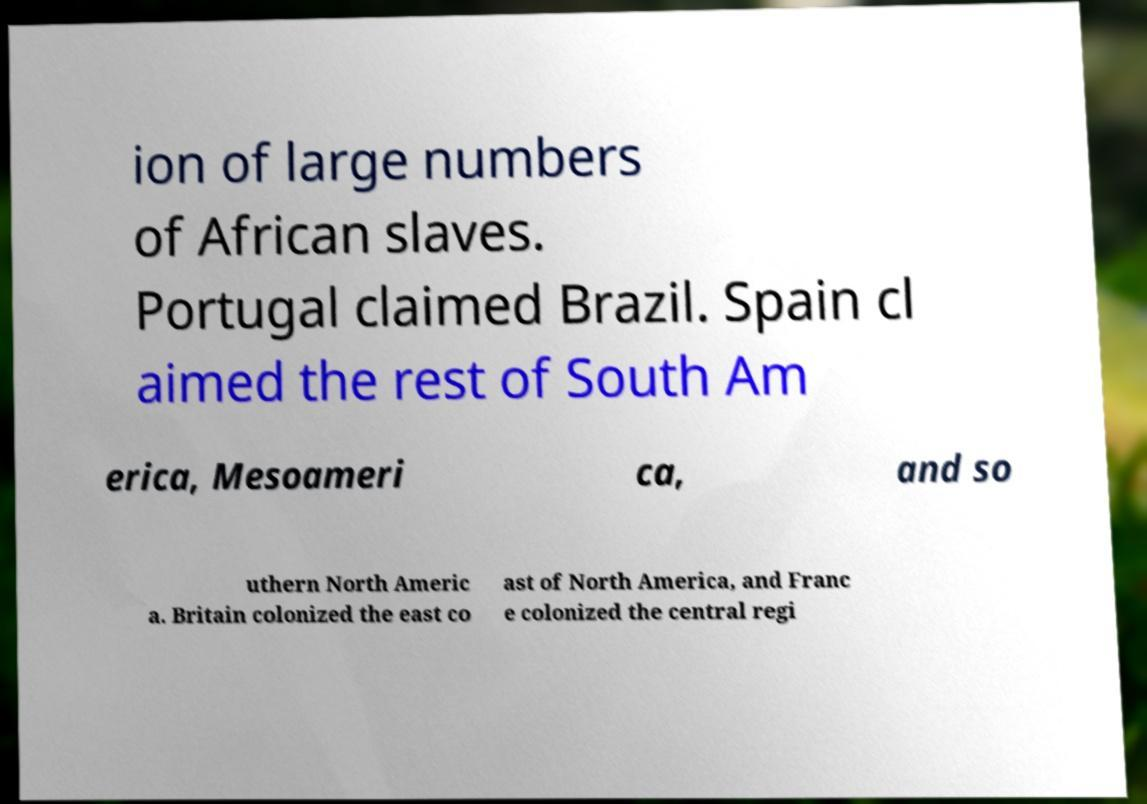Could you assist in decoding the text presented in this image and type it out clearly? ion of large numbers of African slaves. Portugal claimed Brazil. Spain cl aimed the rest of South Am erica, Mesoameri ca, and so uthern North Americ a. Britain colonized the east co ast of North America, and Franc e colonized the central regi 